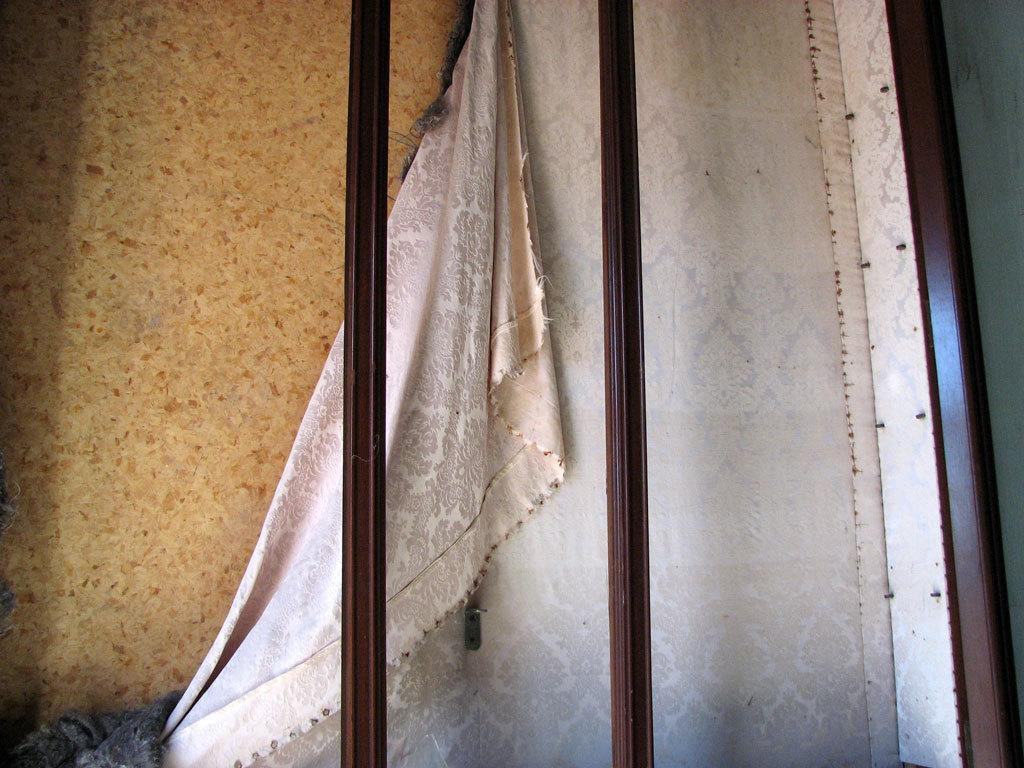What objects can be seen in the foreground of the image? There are iron poles, a curtain, and a wall in the foreground of the image. Can you describe the iron poles in the image? The iron poles are visible in the foreground of the image. What is the purpose of the curtain in the image? The purpose of the curtain in the image is not explicitly stated, but it may be used for privacy or decoration. What type of structure is represented by the wall in the image? The wall in the image is a part of a building or enclosure. Can you tell me how many kitties are playing with apparel on the wall in the image? There are no kitties or apparel present on the wall in the image; it only features a wall and iron poles. What type of boundary is represented by the wall in the image? The wall in the image is not explicitly described as a boundary, but it could be part of a boundary depending on its context and location. 